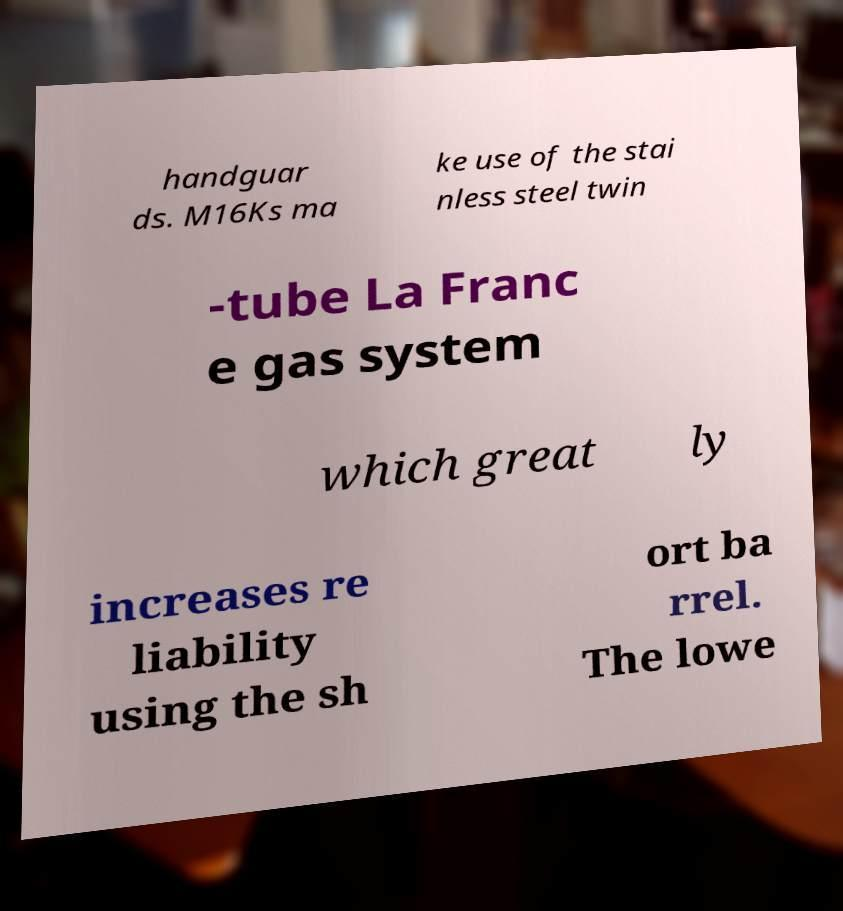For documentation purposes, I need the text within this image transcribed. Could you provide that? handguar ds. M16Ks ma ke use of the stai nless steel twin -tube La Franc e gas system which great ly increases re liability using the sh ort ba rrel. The lowe 